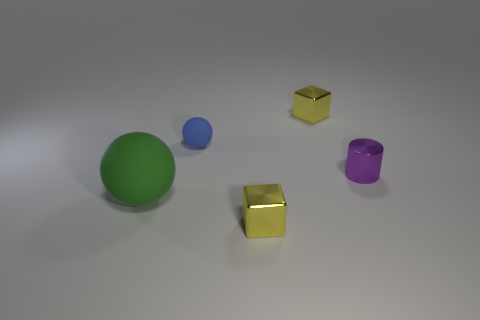What time of day do you think it is in this image? The image appears to be a studio setup without any external lighting cues that would indicate the time of day. 